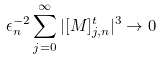<formula> <loc_0><loc_0><loc_500><loc_500>\epsilon _ { n } ^ { - 2 } \sum _ { j = 0 } ^ { \infty } | [ M ] ^ { t } _ { j , n } | ^ { 3 } \to 0</formula> 